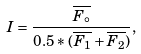<formula> <loc_0><loc_0><loc_500><loc_500>I = \frac { \overline { F _ { \circ } } } { 0 . 5 * ( \overline { F _ { 1 } } + \overline { F _ { 2 } } ) } ,</formula> 